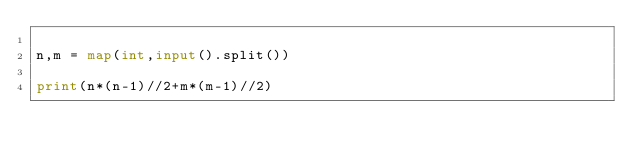<code> <loc_0><loc_0><loc_500><loc_500><_Python_>
n,m = map(int,input().split())

print(n*(n-1)//2+m*(m-1)//2)</code> 